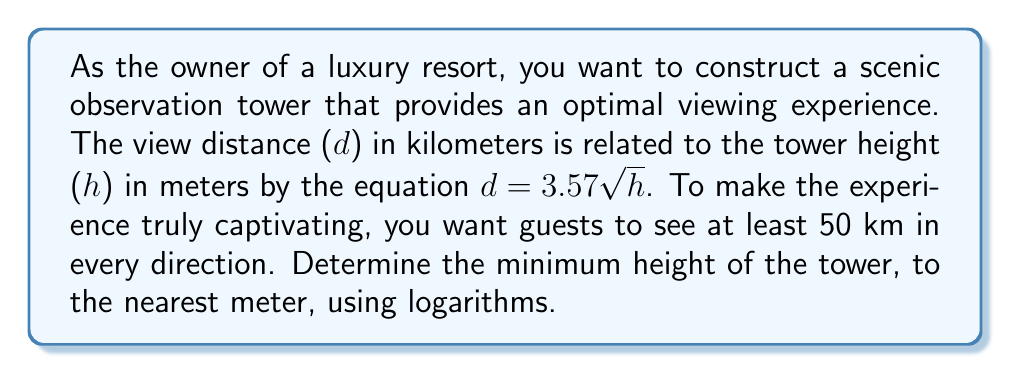Give your solution to this math problem. 1) We start with the equation relating view distance (d) to tower height (h):
   $d = 3.57 \sqrt{h}$

2) We want d to be at least 50 km, so we set up the inequality:
   $50 \leq 3.57 \sqrt{h}$

3) Divide both sides by 3.57:
   $\frac{50}{3.57} \leq \sqrt{h}$

4) Square both sides to isolate h:
   $(\frac{50}{3.57})^2 \leq h$

5) To solve this using logarithms, we can take the log of both sides:
   $\log((\frac{50}{3.57})^2) \leq \log(h)$

6) Using the power property of logarithms:
   $2 \log(\frac{50}{3.57}) \leq \log(h)$

7) Calculate the left side:
   $2 \log(14.0056) \leq \log(h)$
   $2(1.1463) \leq \log(h)$
   $2.2926 \leq \log(h)$

8) To isolate h, we take the antilog (exponential) of both sides:
   $10^{2.2926} \leq h$

9) Calculate:
   $196.2 \leq h$

10) Since we need the minimum height to the nearest meter, we round up:
    $h \geq 197$ meters
Answer: 197 meters 